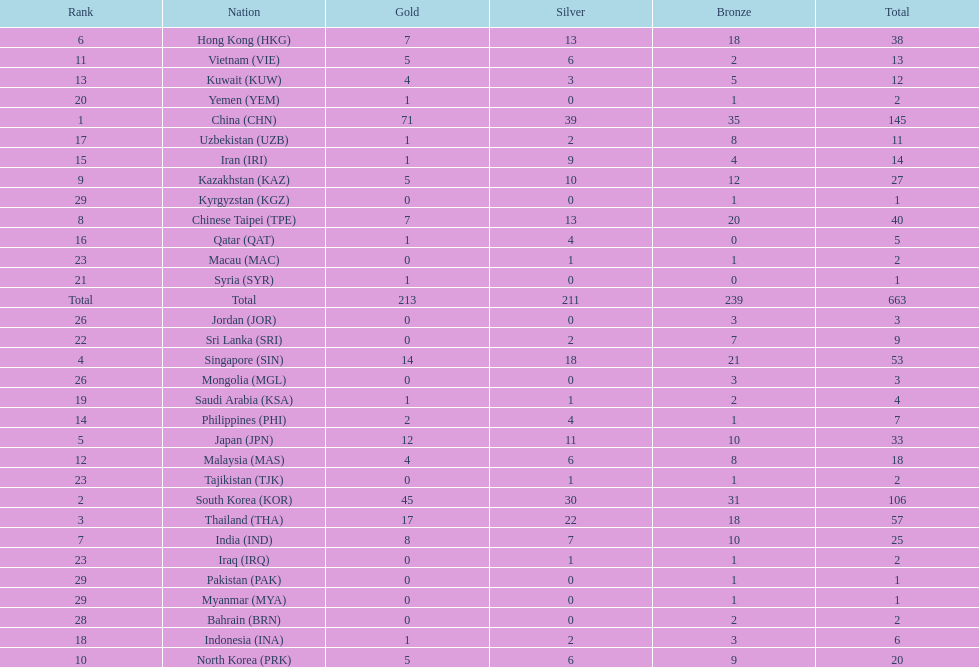Which nation has more gold medals, kuwait or india? India (IND). Parse the full table. {'header': ['Rank', 'Nation', 'Gold', 'Silver', 'Bronze', 'Total'], 'rows': [['6', 'Hong Kong\xa0(HKG)', '7', '13', '18', '38'], ['11', 'Vietnam\xa0(VIE)', '5', '6', '2', '13'], ['13', 'Kuwait\xa0(KUW)', '4', '3', '5', '12'], ['20', 'Yemen\xa0(YEM)', '1', '0', '1', '2'], ['1', 'China\xa0(CHN)', '71', '39', '35', '145'], ['17', 'Uzbekistan\xa0(UZB)', '1', '2', '8', '11'], ['15', 'Iran\xa0(IRI)', '1', '9', '4', '14'], ['9', 'Kazakhstan\xa0(KAZ)', '5', '10', '12', '27'], ['29', 'Kyrgyzstan\xa0(KGZ)', '0', '0', '1', '1'], ['8', 'Chinese Taipei\xa0(TPE)', '7', '13', '20', '40'], ['16', 'Qatar\xa0(QAT)', '1', '4', '0', '5'], ['23', 'Macau\xa0(MAC)', '0', '1', '1', '2'], ['21', 'Syria\xa0(SYR)', '1', '0', '0', '1'], ['Total', 'Total', '213', '211', '239', '663'], ['26', 'Jordan\xa0(JOR)', '0', '0', '3', '3'], ['22', 'Sri Lanka\xa0(SRI)', '0', '2', '7', '9'], ['4', 'Singapore\xa0(SIN)', '14', '18', '21', '53'], ['26', 'Mongolia\xa0(MGL)', '0', '0', '3', '3'], ['19', 'Saudi Arabia\xa0(KSA)', '1', '1', '2', '4'], ['14', 'Philippines\xa0(PHI)', '2', '4', '1', '7'], ['5', 'Japan\xa0(JPN)', '12', '11', '10', '33'], ['12', 'Malaysia\xa0(MAS)', '4', '6', '8', '18'], ['23', 'Tajikistan\xa0(TJK)', '0', '1', '1', '2'], ['2', 'South Korea\xa0(KOR)', '45', '30', '31', '106'], ['3', 'Thailand\xa0(THA)', '17', '22', '18', '57'], ['7', 'India\xa0(IND)', '8', '7', '10', '25'], ['23', 'Iraq\xa0(IRQ)', '0', '1', '1', '2'], ['29', 'Pakistan\xa0(PAK)', '0', '0', '1', '1'], ['29', 'Myanmar\xa0(MYA)', '0', '0', '1', '1'], ['28', 'Bahrain\xa0(BRN)', '0', '0', '2', '2'], ['18', 'Indonesia\xa0(INA)', '1', '2', '3', '6'], ['10', 'North Korea\xa0(PRK)', '5', '6', '9', '20']]} 